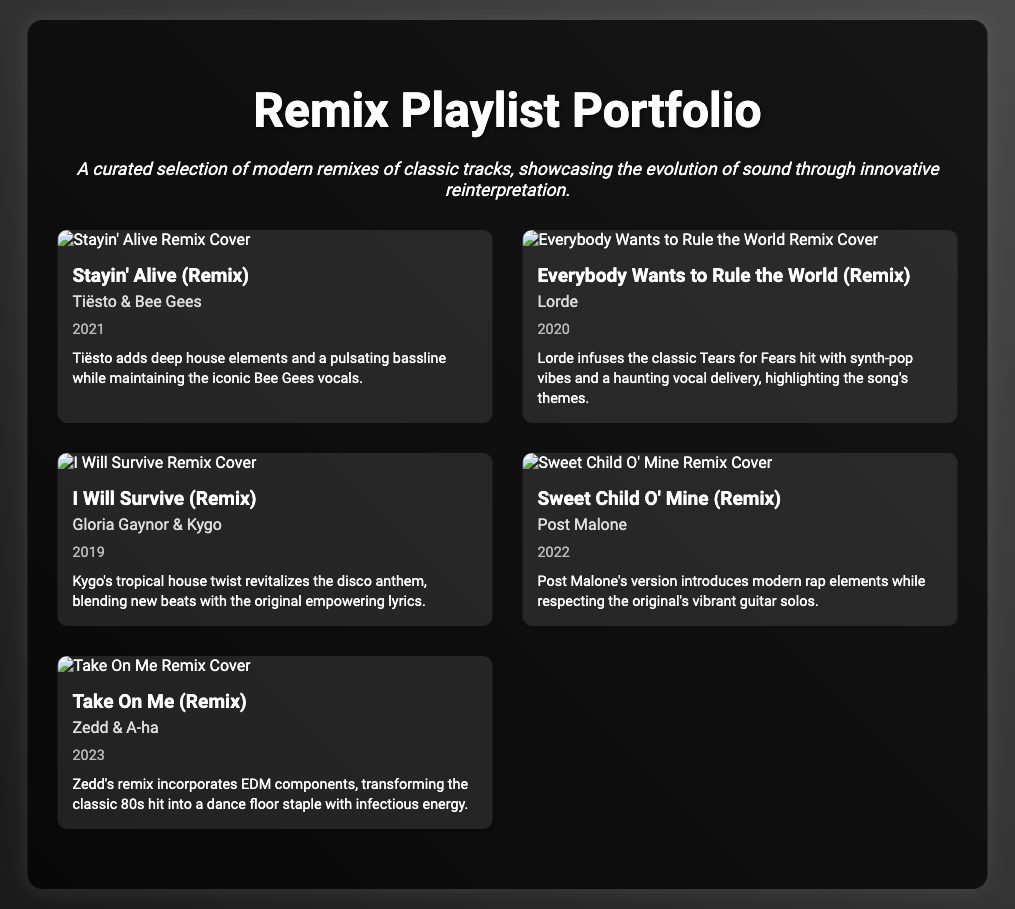What is the title of the first remix in the playlist? The title of the first remix is listed prominently below the cover art, revealing its name.
Answer: Stayin' Alive (Remix) Who is the artist associated with the remix of "Everybody Wants to Rule the World"? The artist's name is found directly below the track title in the information section of the track item.
Answer: Lorde What year was "I Will Survive (Remix)" released? The release year is mentioned in the track details, indicating when the remix became available.
Answer: 2019 Which remix features Post Malone? The name of the artist for the corresponding remix is shown near the title in the track information.
Answer: Sweet Child O' Mine (Remix) What genre does Zedd's remix of "Take On Me" incorporate? The genre is implied through the description of Zedd's remix, highlighting the musical elements added.
Answer: EDM How many tracks are featured in the playlist? The total number of track items can be counted based on the number of distinct track items listed.
Answer: 5 Which remix blends deep house elements with Bee Gees vocals? The specific remix is identified in the production notes, describing the unique elements integrated into it.
Answer: Stayin' Alive (Remix) What is the production note for "Sweet Child O' Mine (Remix)"? The production note provides insight into the remix's style and how it relates to the original song.
Answer: Post Malone's version introduces modern rap elements while respecting the original's vibrant guitar solos Who collaborated with Gloria Gaynor on the "I Will Survive (Remix)"? The collaboration artist is mentioned directly in the track item next to Gloria Gaynor's name in the information.
Answer: Kygo 